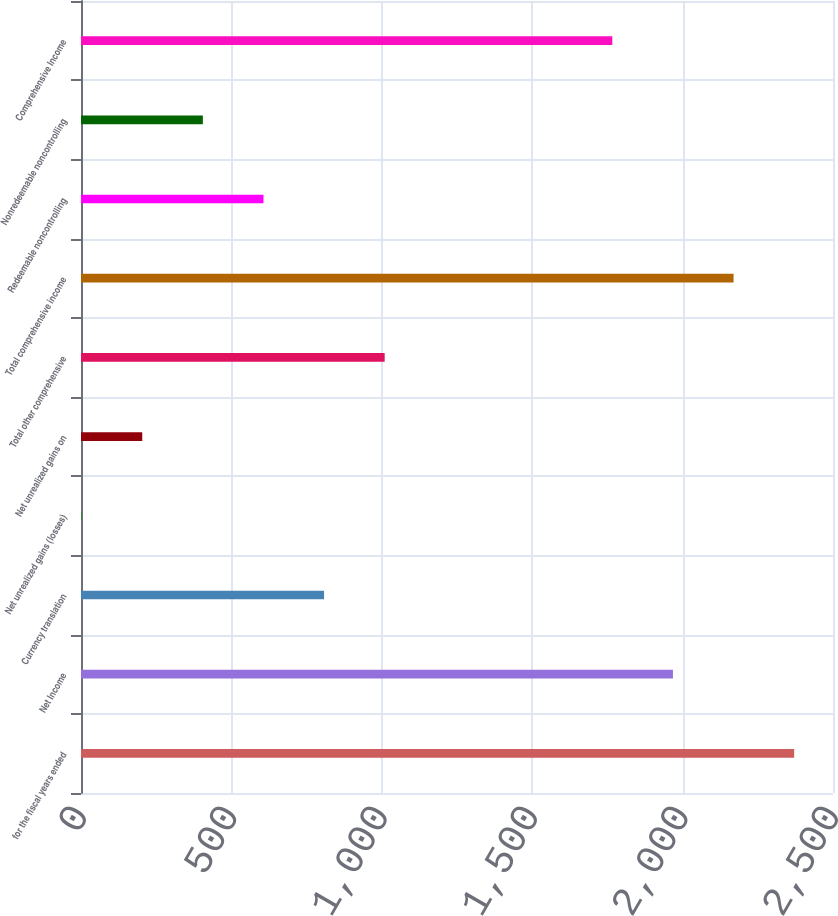<chart> <loc_0><loc_0><loc_500><loc_500><bar_chart><fcel>for the fiscal years ended<fcel>Net Income<fcel>Currency translation<fcel>Net unrealized gains (losses)<fcel>Net unrealized gains on<fcel>Total other comprehensive<fcel>Total comprehensive income<fcel>Redeemable noncontrolling<fcel>Nonredeemable noncontrolling<fcel>Comprehensive Income<nl><fcel>2370.87<fcel>1967.89<fcel>808.06<fcel>2.1<fcel>203.59<fcel>1009.55<fcel>2169.38<fcel>606.57<fcel>405.08<fcel>1766.4<nl></chart> 